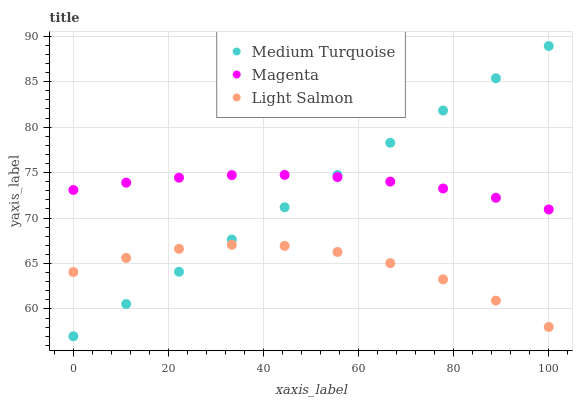Does Light Salmon have the minimum area under the curve?
Answer yes or no. Yes. Does Magenta have the maximum area under the curve?
Answer yes or no. Yes. Does Medium Turquoise have the minimum area under the curve?
Answer yes or no. No. Does Medium Turquoise have the maximum area under the curve?
Answer yes or no. No. Is Medium Turquoise the smoothest?
Answer yes or no. Yes. Is Light Salmon the roughest?
Answer yes or no. Yes. Is Light Salmon the smoothest?
Answer yes or no. No. Is Medium Turquoise the roughest?
Answer yes or no. No. Does Medium Turquoise have the lowest value?
Answer yes or no. Yes. Does Light Salmon have the lowest value?
Answer yes or no. No. Does Medium Turquoise have the highest value?
Answer yes or no. Yes. Does Light Salmon have the highest value?
Answer yes or no. No. Is Light Salmon less than Magenta?
Answer yes or no. Yes. Is Magenta greater than Light Salmon?
Answer yes or no. Yes. Does Light Salmon intersect Medium Turquoise?
Answer yes or no. Yes. Is Light Salmon less than Medium Turquoise?
Answer yes or no. No. Is Light Salmon greater than Medium Turquoise?
Answer yes or no. No. Does Light Salmon intersect Magenta?
Answer yes or no. No. 